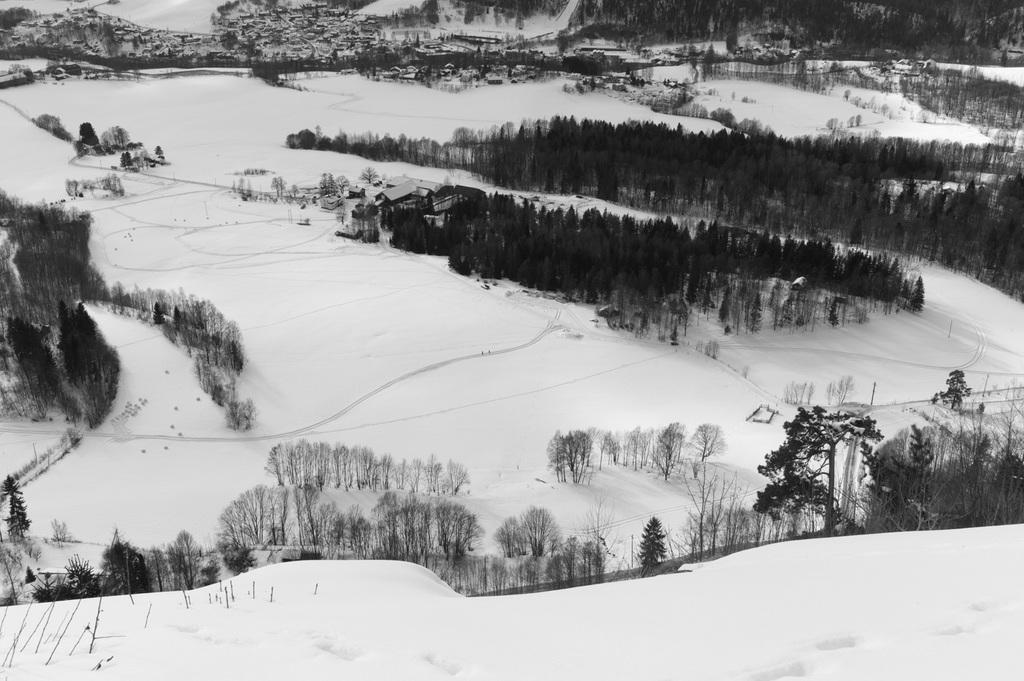What is the condition of the ground in the image? There is snow on the ground in the image. What type of vegetation can be seen in the image? There are green color plants in the image. Are there any tall structures in the image? Yes, there are trees in the image. Can you see a cactus in the image? No, there is no cactus present in the image. How many people are sneezing in the image? There are no people in the image, so it is not possible to determine if anyone is sneezing. 